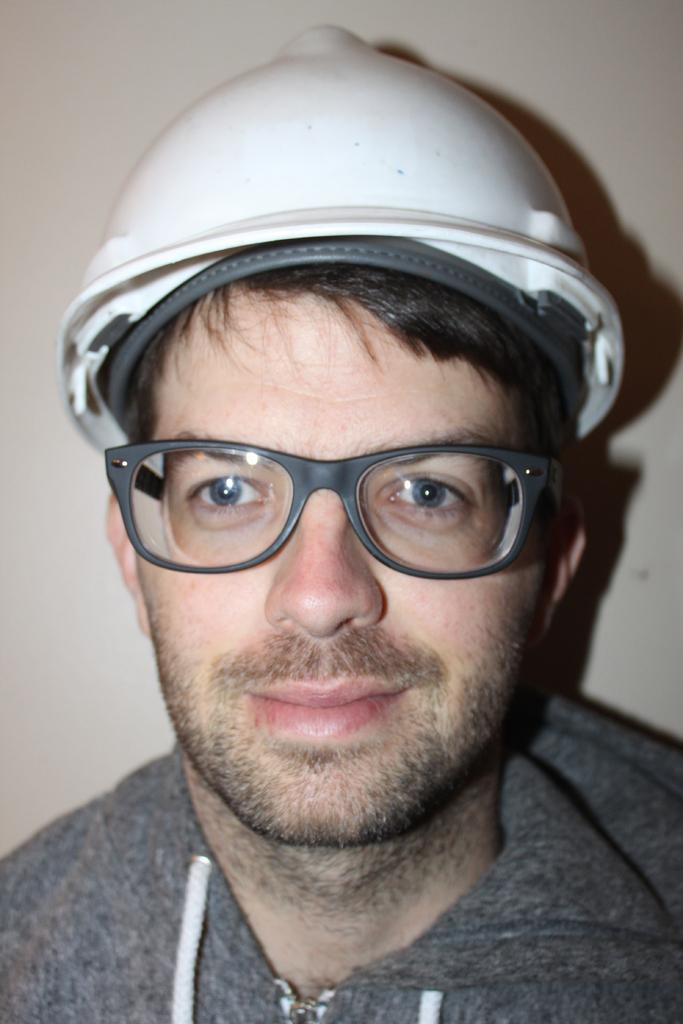What is the main subject of the image? The main subject of the image is a man. What is the man doing in the image? The man is smiling in the image. What is the man wearing on his head? The man is wearing a helmet in the image. What is the color of the wall in the background? The wall in the background is white in color. What type of instrument is the man playing in the image? There is no instrument present in the image; the man is wearing a helmet and smiling. 